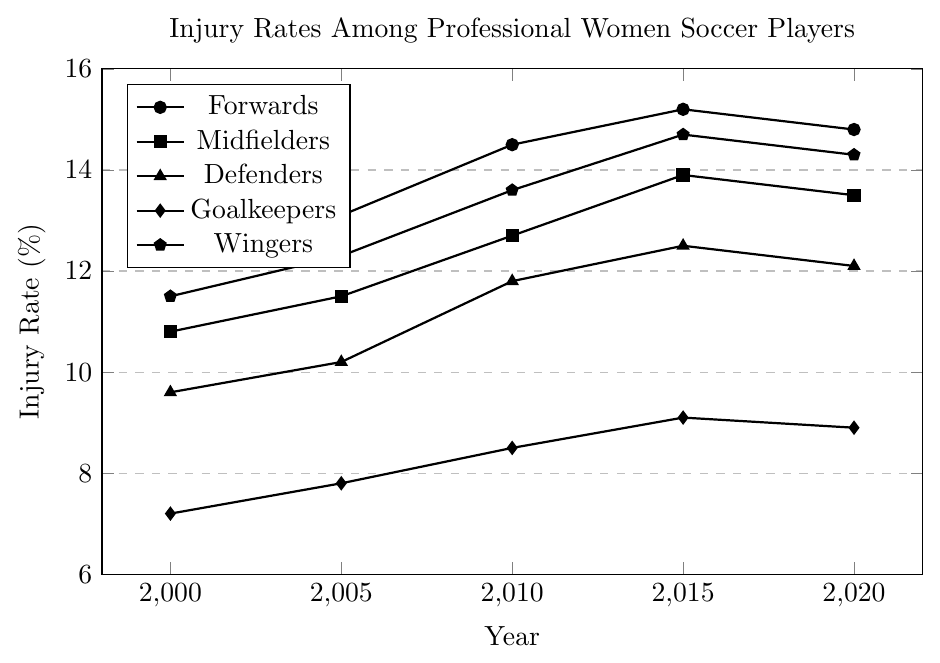What position shows the highest injury rate in 2020? To determine the position with the highest injury rate in 2020, examine the y-values for all positions at the x-coordinate corresponding to 2020. The position with the highest y-value at this point is the one with the highest injury rate.
Answer: Forwards Which position had the largest increase in injury rate from 2000 to 2020? Calculate the difference in injury rate for each position between 2000 and 2020. Compare these differences to find the largest one. Forwards increased by (14.8 - 12.3 = 2.5), Midfielders by (13.5 - 10.8 = 2.7), Defenders by (12.1 - 9.6 = 2.5), Goalkeepers by (8.9 - 7.2 = 1.7), and Wingers by (14.3 - 11.5 = 2.8).
Answer: Wingers Did any position's injury rate decrease between 2015 and 2020? Compare the injury rates for each position between 2015 and 2020. If the value in 2020 is less than the value in 2015 for any position, then that position saw a decrease. Forwards (15.2 to 14.8), Midfielders (13.9 to 13.5), Defenders (12.5 to 12.1), Goalkeepers (9.1 to 8.9), and Wingers (14.7 to 14.3).
Answer: Yes What is the average injury rate for Goalkeepers across all the years presented? To calculate the average injury rate for Goalkeepers, sum the injury rates for Goalkeepers from 2000, 2005, 2010, 2015, and 2020, and divide by the number of years. (7.2 + 7.8 + 8.5 + 9.1 + 8.9) / 5 = 41.5 / 5 = 8.3
Answer: 8.3 Which two positions had the closest injury rates in 2010? Compare the injury rates for all the positions in 2010. Find the two positions with the smallest difference between their injury rates. Injury rates are Forwards (14.5), Midfielders (12.7), Defenders (11.8), Goalkeepers (8.5), and Wingers (13.6). The closest rates are Midfielders (12.7) and Wingers (13.6), with a difference of 0.9.
Answer: Midfielders and Wingers Which position consistently had the lowest injury rate over the years? Examine the injury rates for each position across all years and identify the one with the lowest rates consistently. Goalkeepers had the lowest injury rates in each year (7.2, 7.8, 8.5, 9.1, 8.9).
Answer: Goalkeepers 